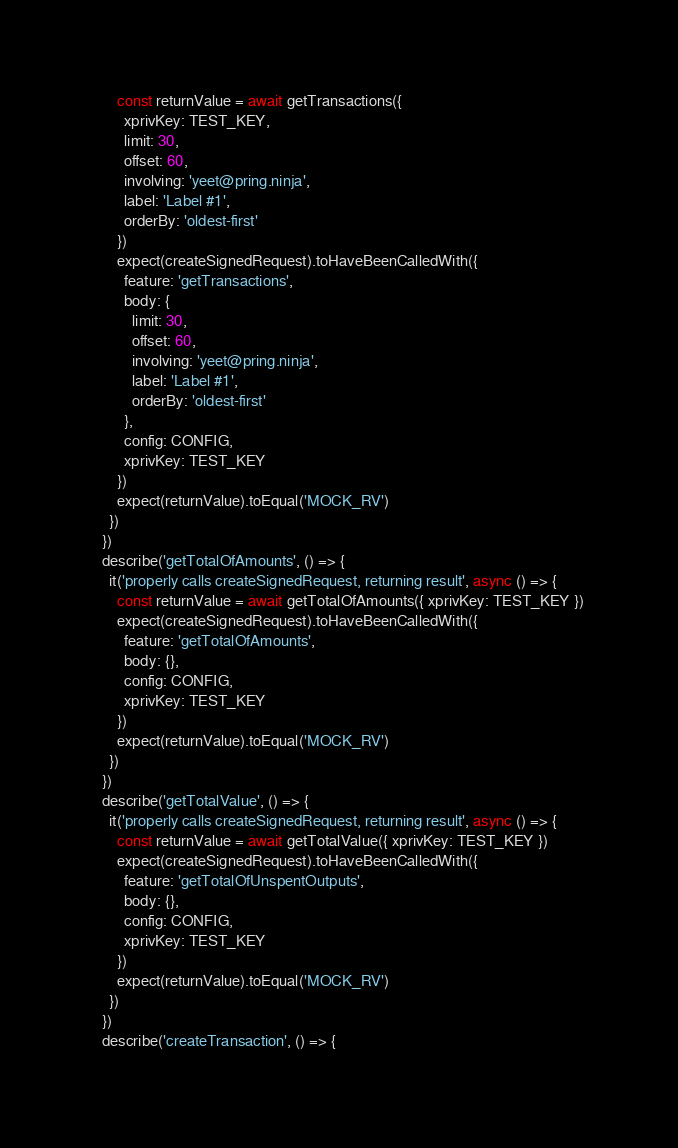<code> <loc_0><loc_0><loc_500><loc_500><_JavaScript_>      const returnValue = await getTransactions({
        xprivKey: TEST_KEY,
        limit: 30,
        offset: 60,
        involving: 'yeet@pring.ninja',
        label: 'Label #1',
        orderBy: 'oldest-first'
      })
      expect(createSignedRequest).toHaveBeenCalledWith({
        feature: 'getTransactions',
        body: {
          limit: 30,
          offset: 60,
          involving: 'yeet@pring.ninja',
          label: 'Label #1',
          orderBy: 'oldest-first'
        },
        config: CONFIG,
        xprivKey: TEST_KEY
      })
      expect(returnValue).toEqual('MOCK_RV')
    })
  })
  describe('getTotalOfAmounts', () => {
    it('properly calls createSignedRequest, returning result', async () => {
      const returnValue = await getTotalOfAmounts({ xprivKey: TEST_KEY })
      expect(createSignedRequest).toHaveBeenCalledWith({
        feature: 'getTotalOfAmounts',
        body: {},
        config: CONFIG,
        xprivKey: TEST_KEY
      })
      expect(returnValue).toEqual('MOCK_RV')
    })
  })
  describe('getTotalValue', () => {
    it('properly calls createSignedRequest, returning result', async () => {
      const returnValue = await getTotalValue({ xprivKey: TEST_KEY })
      expect(createSignedRequest).toHaveBeenCalledWith({
        feature: 'getTotalOfUnspentOutputs',
        body: {},
        config: CONFIG,
        xprivKey: TEST_KEY
      })
      expect(returnValue).toEqual('MOCK_RV')
    })
  })
  describe('createTransaction', () => {</code> 